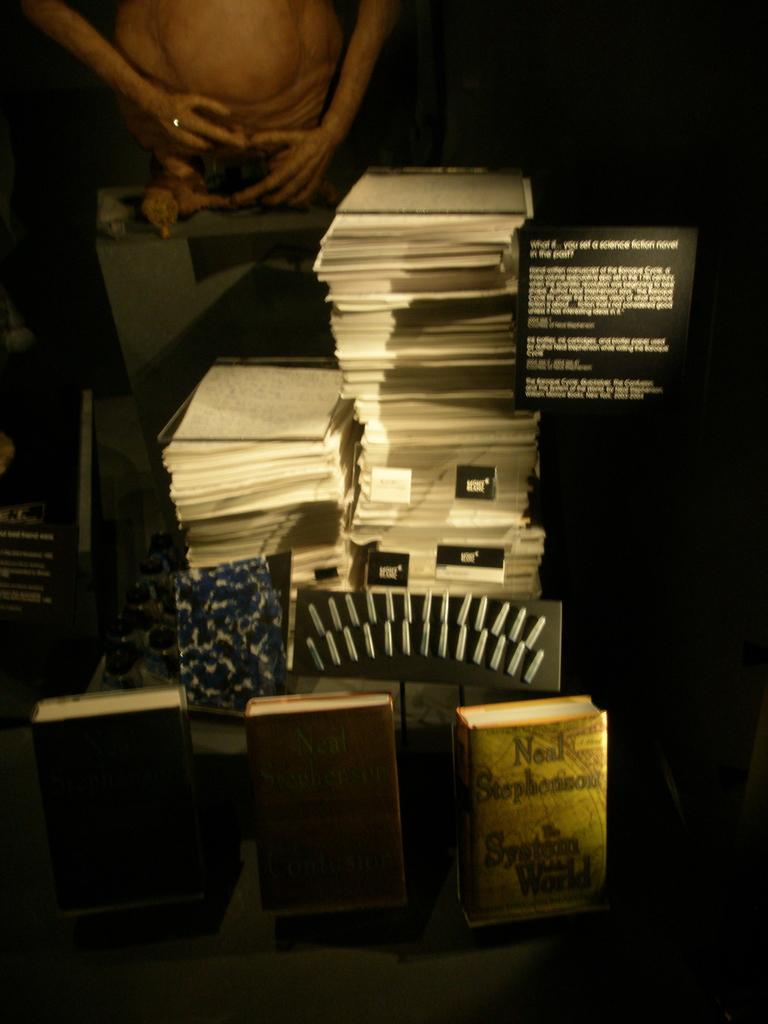What is neal's last name?
Your response must be concise. Stephenson. 